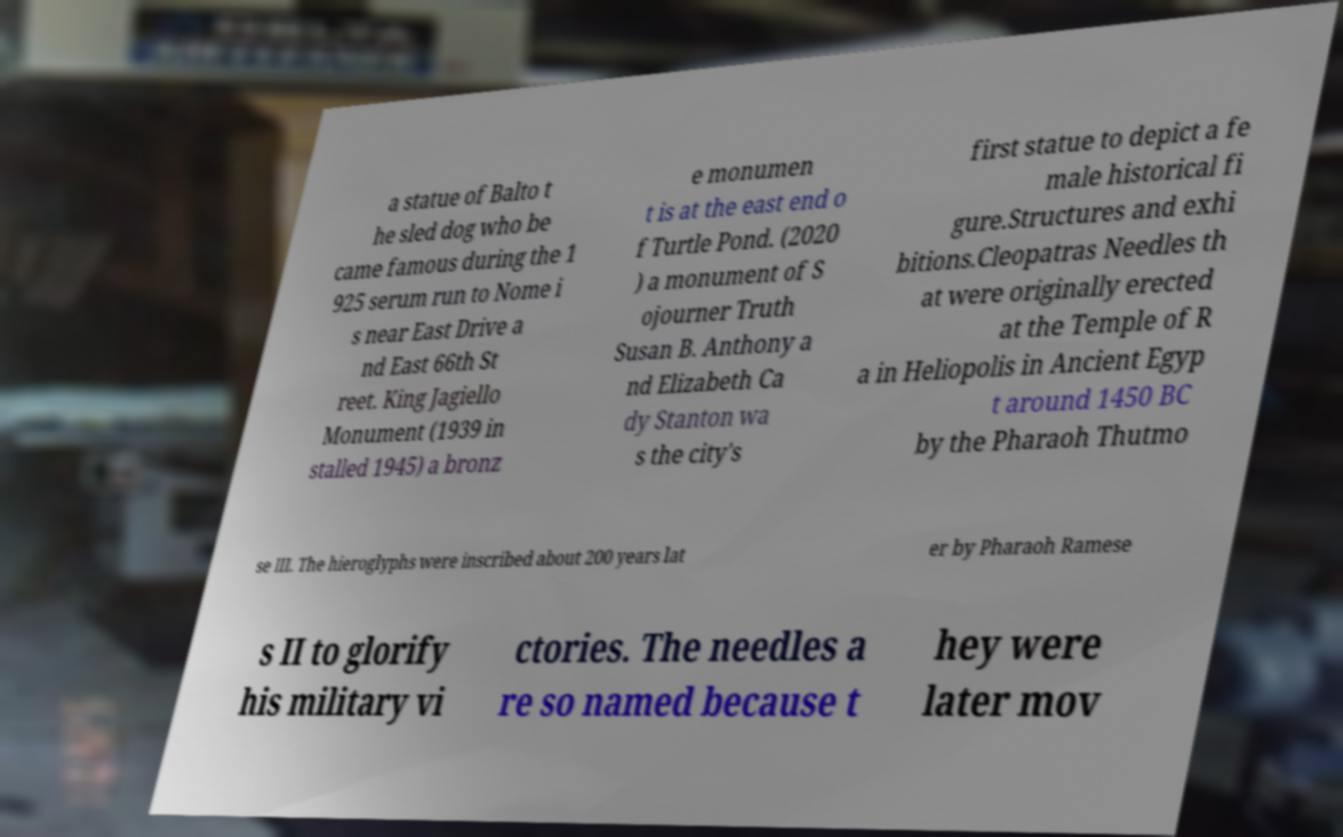Can you accurately transcribe the text from the provided image for me? a statue of Balto t he sled dog who be came famous during the 1 925 serum run to Nome i s near East Drive a nd East 66th St reet. King Jagiello Monument (1939 in stalled 1945) a bronz e monumen t is at the east end o f Turtle Pond. (2020 ) a monument of S ojourner Truth Susan B. Anthony a nd Elizabeth Ca dy Stanton wa s the city's first statue to depict a fe male historical fi gure.Structures and exhi bitions.Cleopatras Needles th at were originally erected at the Temple of R a in Heliopolis in Ancient Egyp t around 1450 BC by the Pharaoh Thutmo se III. The hieroglyphs were inscribed about 200 years lat er by Pharaoh Ramese s II to glorify his military vi ctories. The needles a re so named because t hey were later mov 